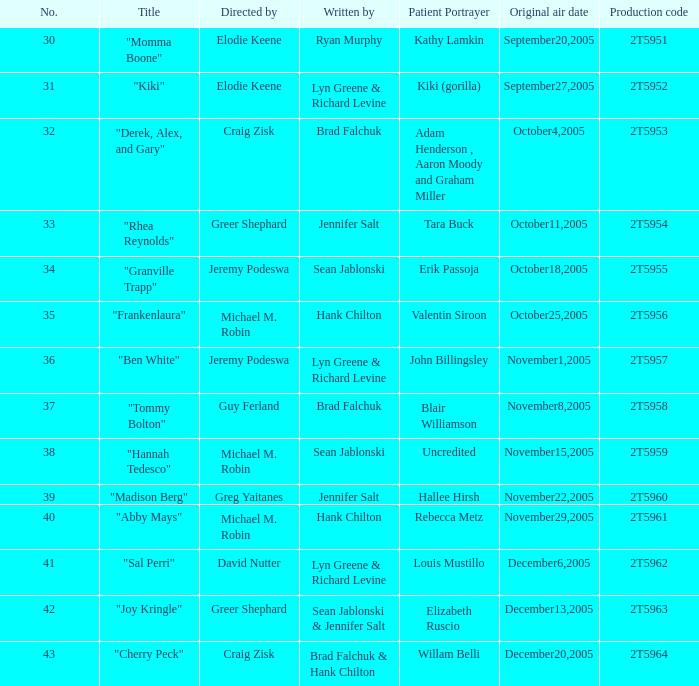Give me the full table as a dictionary. {'header': ['No.', 'Title', 'Directed by', 'Written by', 'Patient Portrayer', 'Original air date', 'Production code'], 'rows': [['30', '"Momma Boone"', 'Elodie Keene', 'Ryan Murphy', 'Kathy Lamkin', 'September20,2005', '2T5951'], ['31', '"Kiki"', 'Elodie Keene', 'Lyn Greene & Richard Levine', 'Kiki (gorilla)', 'September27,2005', '2T5952'], ['32', '"Derek, Alex, and Gary"', 'Craig Zisk', 'Brad Falchuk', 'Adam Henderson , Aaron Moody and Graham Miller', 'October4,2005', '2T5953'], ['33', '"Rhea Reynolds"', 'Greer Shephard', 'Jennifer Salt', 'Tara Buck', 'October11,2005', '2T5954'], ['34', '"Granville Trapp"', 'Jeremy Podeswa', 'Sean Jablonski', 'Erik Passoja', 'October18,2005', '2T5955'], ['35', '"Frankenlaura"', 'Michael M. Robin', 'Hank Chilton', 'Valentin Siroon', 'October25,2005', '2T5956'], ['36', '"Ben White"', 'Jeremy Podeswa', 'Lyn Greene & Richard Levine', 'John Billingsley', 'November1,2005', '2T5957'], ['37', '"Tommy Bolton"', 'Guy Ferland', 'Brad Falchuk', 'Blair Williamson', 'November8,2005', '2T5958'], ['38', '"Hannah Tedesco"', 'Michael M. Robin', 'Sean Jablonski', 'Uncredited', 'November15,2005', '2T5959'], ['39', '"Madison Berg"', 'Greg Yaitanes', 'Jennifer Salt', 'Hallee Hirsh', 'November22,2005', '2T5960'], ['40', '"Abby Mays"', 'Michael M. Robin', 'Hank Chilton', 'Rebecca Metz', 'November29,2005', '2T5961'], ['41', '"Sal Perri"', 'David Nutter', 'Lyn Greene & Richard Levine', 'Louis Mustillo', 'December6,2005', '2T5962'], ['42', '"Joy Kringle"', 'Greer Shephard', 'Sean Jablonski & Jennifer Salt', 'Elizabeth Ruscio', 'December13,2005', '2T5963'], ['43', '"Cherry Peck"', 'Craig Zisk', 'Brad Falchuk & Hank Chilton', 'Willam Belli', 'December20,2005', '2T5964']]} What is the aggregate quantity of patient thespians in the episode directed by craig zisk and composed by brad falchuk? 1.0. 